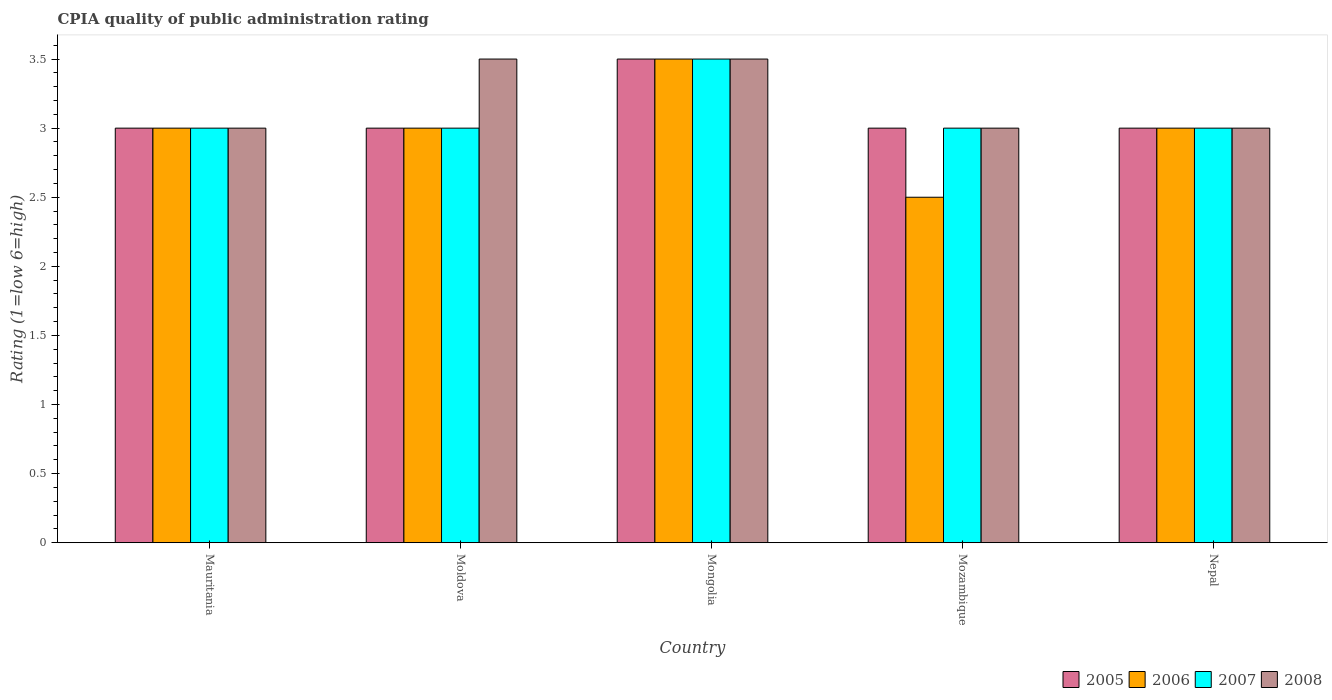How many different coloured bars are there?
Offer a terse response. 4. How many groups of bars are there?
Offer a very short reply. 5. Are the number of bars per tick equal to the number of legend labels?
Provide a succinct answer. Yes. How many bars are there on the 2nd tick from the left?
Your answer should be compact. 4. How many bars are there on the 3rd tick from the right?
Give a very brief answer. 4. What is the label of the 3rd group of bars from the left?
Offer a terse response. Mongolia. In how many cases, is the number of bars for a given country not equal to the number of legend labels?
Your answer should be compact. 0. What is the CPIA rating in 2008 in Mauritania?
Your response must be concise. 3. Across all countries, what is the maximum CPIA rating in 2006?
Offer a terse response. 3.5. In which country was the CPIA rating in 2006 maximum?
Give a very brief answer. Mongolia. In which country was the CPIA rating in 2006 minimum?
Offer a very short reply. Mozambique. What is the total CPIA rating in 2008 in the graph?
Ensure brevity in your answer.  16. What is the difference between the CPIA rating in 2006 in Mongolia and that in Mozambique?
Give a very brief answer. 1. What is the average CPIA rating in 2007 per country?
Offer a terse response. 3.1. What is the ratio of the CPIA rating in 2006 in Mauritania to that in Nepal?
Give a very brief answer. 1. Is the difference between the CPIA rating in 2008 in Mongolia and Mozambique greater than the difference between the CPIA rating in 2006 in Mongolia and Mozambique?
Your answer should be compact. No. What is the difference between the highest and the second highest CPIA rating in 2006?
Provide a short and direct response. -0.5. What is the difference between the highest and the lowest CPIA rating in 2008?
Your answer should be very brief. 0.5. In how many countries, is the CPIA rating in 2007 greater than the average CPIA rating in 2007 taken over all countries?
Your answer should be very brief. 1. What does the 1st bar from the right in Moldova represents?
Provide a succinct answer. 2008. Is it the case that in every country, the sum of the CPIA rating in 2005 and CPIA rating in 2008 is greater than the CPIA rating in 2007?
Provide a short and direct response. Yes. How many bars are there?
Your answer should be compact. 20. How many countries are there in the graph?
Ensure brevity in your answer.  5. What is the difference between two consecutive major ticks on the Y-axis?
Offer a terse response. 0.5. Are the values on the major ticks of Y-axis written in scientific E-notation?
Ensure brevity in your answer.  No. How many legend labels are there?
Ensure brevity in your answer.  4. How are the legend labels stacked?
Your response must be concise. Horizontal. What is the title of the graph?
Provide a succinct answer. CPIA quality of public administration rating. Does "2004" appear as one of the legend labels in the graph?
Ensure brevity in your answer.  No. What is the label or title of the X-axis?
Give a very brief answer. Country. What is the Rating (1=low 6=high) of 2006 in Mauritania?
Make the answer very short. 3. What is the Rating (1=low 6=high) of 2006 in Moldova?
Keep it short and to the point. 3. What is the Rating (1=low 6=high) in 2007 in Mongolia?
Provide a succinct answer. 3.5. What is the Rating (1=low 6=high) of 2007 in Mozambique?
Your response must be concise. 3. What is the Rating (1=low 6=high) of 2008 in Mozambique?
Provide a short and direct response. 3. What is the Rating (1=low 6=high) of 2006 in Nepal?
Provide a succinct answer. 3. What is the Rating (1=low 6=high) in 2007 in Nepal?
Your response must be concise. 3. What is the Rating (1=low 6=high) in 2008 in Nepal?
Make the answer very short. 3. Across all countries, what is the maximum Rating (1=low 6=high) of 2005?
Your answer should be compact. 3.5. Across all countries, what is the maximum Rating (1=low 6=high) of 2006?
Ensure brevity in your answer.  3.5. Across all countries, what is the minimum Rating (1=low 6=high) in 2005?
Offer a terse response. 3. Across all countries, what is the minimum Rating (1=low 6=high) in 2006?
Your answer should be very brief. 2.5. Across all countries, what is the minimum Rating (1=low 6=high) of 2007?
Offer a terse response. 3. Across all countries, what is the minimum Rating (1=low 6=high) of 2008?
Provide a succinct answer. 3. What is the total Rating (1=low 6=high) in 2005 in the graph?
Your answer should be very brief. 15.5. What is the total Rating (1=low 6=high) in 2006 in the graph?
Offer a terse response. 15. What is the total Rating (1=low 6=high) of 2007 in the graph?
Make the answer very short. 15.5. What is the difference between the Rating (1=low 6=high) of 2006 in Mauritania and that in Moldova?
Make the answer very short. 0. What is the difference between the Rating (1=low 6=high) of 2005 in Mauritania and that in Mongolia?
Give a very brief answer. -0.5. What is the difference between the Rating (1=low 6=high) of 2006 in Mauritania and that in Mongolia?
Provide a succinct answer. -0.5. What is the difference between the Rating (1=low 6=high) in 2005 in Mauritania and that in Mozambique?
Provide a short and direct response. 0. What is the difference between the Rating (1=low 6=high) in 2007 in Mauritania and that in Mozambique?
Provide a succinct answer. 0. What is the difference between the Rating (1=low 6=high) in 2008 in Mauritania and that in Mozambique?
Your response must be concise. 0. What is the difference between the Rating (1=low 6=high) of 2005 in Mauritania and that in Nepal?
Your answer should be very brief. 0. What is the difference between the Rating (1=low 6=high) of 2005 in Moldova and that in Mongolia?
Give a very brief answer. -0.5. What is the difference between the Rating (1=low 6=high) of 2006 in Moldova and that in Mongolia?
Your answer should be compact. -0.5. What is the difference between the Rating (1=low 6=high) of 2007 in Moldova and that in Mongolia?
Keep it short and to the point. -0.5. What is the difference between the Rating (1=low 6=high) of 2008 in Moldova and that in Mongolia?
Your response must be concise. 0. What is the difference between the Rating (1=low 6=high) of 2005 in Moldova and that in Mozambique?
Offer a very short reply. 0. What is the difference between the Rating (1=low 6=high) in 2006 in Moldova and that in Mozambique?
Make the answer very short. 0.5. What is the difference between the Rating (1=low 6=high) of 2005 in Moldova and that in Nepal?
Your response must be concise. 0. What is the difference between the Rating (1=low 6=high) in 2007 in Moldova and that in Nepal?
Your answer should be compact. 0. What is the difference between the Rating (1=low 6=high) of 2005 in Mongolia and that in Mozambique?
Your answer should be compact. 0.5. What is the difference between the Rating (1=low 6=high) in 2006 in Mongolia and that in Mozambique?
Make the answer very short. 1. What is the difference between the Rating (1=low 6=high) in 2006 in Mongolia and that in Nepal?
Your response must be concise. 0.5. What is the difference between the Rating (1=low 6=high) of 2007 in Mongolia and that in Nepal?
Provide a succinct answer. 0.5. What is the difference between the Rating (1=low 6=high) of 2005 in Mauritania and the Rating (1=low 6=high) of 2007 in Moldova?
Keep it short and to the point. 0. What is the difference between the Rating (1=low 6=high) of 2006 in Mauritania and the Rating (1=low 6=high) of 2007 in Moldova?
Ensure brevity in your answer.  0. What is the difference between the Rating (1=low 6=high) of 2007 in Mauritania and the Rating (1=low 6=high) of 2008 in Moldova?
Your response must be concise. -0.5. What is the difference between the Rating (1=low 6=high) of 2005 in Mauritania and the Rating (1=low 6=high) of 2006 in Mongolia?
Keep it short and to the point. -0.5. What is the difference between the Rating (1=low 6=high) of 2005 in Mauritania and the Rating (1=low 6=high) of 2008 in Mongolia?
Your answer should be compact. -0.5. What is the difference between the Rating (1=low 6=high) of 2006 in Mauritania and the Rating (1=low 6=high) of 2007 in Mongolia?
Make the answer very short. -0.5. What is the difference between the Rating (1=low 6=high) in 2005 in Mauritania and the Rating (1=low 6=high) in 2006 in Mozambique?
Your answer should be very brief. 0.5. What is the difference between the Rating (1=low 6=high) of 2006 in Mauritania and the Rating (1=low 6=high) of 2008 in Mozambique?
Your response must be concise. 0. What is the difference between the Rating (1=low 6=high) of 2005 in Mauritania and the Rating (1=low 6=high) of 2006 in Nepal?
Provide a short and direct response. 0. What is the difference between the Rating (1=low 6=high) of 2006 in Mauritania and the Rating (1=low 6=high) of 2007 in Nepal?
Provide a succinct answer. 0. What is the difference between the Rating (1=low 6=high) in 2006 in Mauritania and the Rating (1=low 6=high) in 2008 in Nepal?
Give a very brief answer. 0. What is the difference between the Rating (1=low 6=high) in 2005 in Moldova and the Rating (1=low 6=high) in 2006 in Mongolia?
Make the answer very short. -0.5. What is the difference between the Rating (1=low 6=high) in 2006 in Moldova and the Rating (1=low 6=high) in 2008 in Mongolia?
Your answer should be compact. -0.5. What is the difference between the Rating (1=low 6=high) in 2007 in Moldova and the Rating (1=low 6=high) in 2008 in Mongolia?
Provide a succinct answer. -0.5. What is the difference between the Rating (1=low 6=high) in 2005 in Moldova and the Rating (1=low 6=high) in 2006 in Mozambique?
Your answer should be very brief. 0.5. What is the difference between the Rating (1=low 6=high) in 2005 in Moldova and the Rating (1=low 6=high) in 2007 in Mozambique?
Your response must be concise. 0. What is the difference between the Rating (1=low 6=high) of 2006 in Moldova and the Rating (1=low 6=high) of 2007 in Mozambique?
Provide a short and direct response. 0. What is the difference between the Rating (1=low 6=high) in 2006 in Moldova and the Rating (1=low 6=high) in 2008 in Mozambique?
Provide a short and direct response. 0. What is the difference between the Rating (1=low 6=high) of 2007 in Moldova and the Rating (1=low 6=high) of 2008 in Mozambique?
Provide a short and direct response. 0. What is the difference between the Rating (1=low 6=high) of 2005 in Moldova and the Rating (1=low 6=high) of 2007 in Nepal?
Make the answer very short. 0. What is the difference between the Rating (1=low 6=high) of 2005 in Moldova and the Rating (1=low 6=high) of 2008 in Nepal?
Provide a succinct answer. 0. What is the difference between the Rating (1=low 6=high) in 2006 in Moldova and the Rating (1=low 6=high) in 2007 in Nepal?
Keep it short and to the point. 0. What is the difference between the Rating (1=low 6=high) in 2006 in Moldova and the Rating (1=low 6=high) in 2008 in Nepal?
Provide a succinct answer. 0. What is the difference between the Rating (1=low 6=high) in 2005 in Mongolia and the Rating (1=low 6=high) in 2006 in Mozambique?
Provide a succinct answer. 1. What is the difference between the Rating (1=low 6=high) in 2005 in Mongolia and the Rating (1=low 6=high) in 2007 in Mozambique?
Keep it short and to the point. 0.5. What is the difference between the Rating (1=low 6=high) in 2005 in Mongolia and the Rating (1=low 6=high) in 2006 in Nepal?
Your response must be concise. 0.5. What is the difference between the Rating (1=low 6=high) of 2005 in Mongolia and the Rating (1=low 6=high) of 2007 in Nepal?
Provide a short and direct response. 0.5. What is the difference between the Rating (1=low 6=high) in 2006 in Mongolia and the Rating (1=low 6=high) in 2007 in Nepal?
Your answer should be compact. 0.5. What is the difference between the Rating (1=low 6=high) in 2005 in Mozambique and the Rating (1=low 6=high) in 2006 in Nepal?
Ensure brevity in your answer.  0. What is the difference between the Rating (1=low 6=high) of 2005 in Mozambique and the Rating (1=low 6=high) of 2007 in Nepal?
Offer a terse response. 0. What is the difference between the Rating (1=low 6=high) in 2005 in Mozambique and the Rating (1=low 6=high) in 2008 in Nepal?
Give a very brief answer. 0. What is the difference between the Rating (1=low 6=high) of 2006 in Mozambique and the Rating (1=low 6=high) of 2007 in Nepal?
Offer a very short reply. -0.5. What is the difference between the Rating (1=low 6=high) of 2006 in Mozambique and the Rating (1=low 6=high) of 2008 in Nepal?
Offer a very short reply. -0.5. What is the difference between the Rating (1=low 6=high) in 2007 in Mozambique and the Rating (1=low 6=high) in 2008 in Nepal?
Ensure brevity in your answer.  0. What is the average Rating (1=low 6=high) of 2005 per country?
Offer a terse response. 3.1. What is the average Rating (1=low 6=high) in 2006 per country?
Your response must be concise. 3. What is the average Rating (1=low 6=high) of 2008 per country?
Offer a very short reply. 3.2. What is the difference between the Rating (1=low 6=high) of 2006 and Rating (1=low 6=high) of 2008 in Mauritania?
Offer a very short reply. 0. What is the difference between the Rating (1=low 6=high) of 2007 and Rating (1=low 6=high) of 2008 in Mauritania?
Provide a succinct answer. 0. What is the difference between the Rating (1=low 6=high) in 2005 and Rating (1=low 6=high) in 2008 in Moldova?
Your answer should be compact. -0.5. What is the difference between the Rating (1=low 6=high) of 2007 and Rating (1=low 6=high) of 2008 in Moldova?
Provide a short and direct response. -0.5. What is the difference between the Rating (1=low 6=high) of 2005 and Rating (1=low 6=high) of 2007 in Mongolia?
Give a very brief answer. 0. What is the difference between the Rating (1=low 6=high) of 2005 and Rating (1=low 6=high) of 2008 in Mongolia?
Give a very brief answer. 0. What is the difference between the Rating (1=low 6=high) in 2006 and Rating (1=low 6=high) in 2007 in Mongolia?
Ensure brevity in your answer.  0. What is the difference between the Rating (1=low 6=high) in 2007 and Rating (1=low 6=high) in 2008 in Mongolia?
Provide a succinct answer. 0. What is the difference between the Rating (1=low 6=high) of 2005 and Rating (1=low 6=high) of 2008 in Mozambique?
Offer a very short reply. 0. What is the difference between the Rating (1=low 6=high) in 2006 and Rating (1=low 6=high) in 2007 in Mozambique?
Provide a succinct answer. -0.5. What is the difference between the Rating (1=low 6=high) of 2006 and Rating (1=low 6=high) of 2008 in Mozambique?
Your answer should be very brief. -0.5. What is the difference between the Rating (1=low 6=high) of 2005 and Rating (1=low 6=high) of 2007 in Nepal?
Provide a short and direct response. 0. What is the difference between the Rating (1=low 6=high) of 2006 and Rating (1=low 6=high) of 2008 in Nepal?
Offer a very short reply. 0. What is the ratio of the Rating (1=low 6=high) in 2005 in Mauritania to that in Moldova?
Keep it short and to the point. 1. What is the ratio of the Rating (1=low 6=high) in 2008 in Mauritania to that in Moldova?
Ensure brevity in your answer.  0.86. What is the ratio of the Rating (1=low 6=high) in 2005 in Mauritania to that in Mongolia?
Your answer should be very brief. 0.86. What is the ratio of the Rating (1=low 6=high) in 2006 in Mauritania to that in Mongolia?
Your answer should be very brief. 0.86. What is the ratio of the Rating (1=low 6=high) in 2006 in Mauritania to that in Mozambique?
Give a very brief answer. 1.2. What is the ratio of the Rating (1=low 6=high) of 2007 in Mauritania to that in Mozambique?
Offer a terse response. 1. What is the ratio of the Rating (1=low 6=high) in 2008 in Mauritania to that in Mozambique?
Make the answer very short. 1. What is the ratio of the Rating (1=low 6=high) of 2006 in Mauritania to that in Nepal?
Your response must be concise. 1. What is the ratio of the Rating (1=low 6=high) of 2007 in Mauritania to that in Nepal?
Give a very brief answer. 1. What is the ratio of the Rating (1=low 6=high) in 2005 in Moldova to that in Mongolia?
Your response must be concise. 0.86. What is the ratio of the Rating (1=low 6=high) of 2008 in Moldova to that in Mongolia?
Your response must be concise. 1. What is the ratio of the Rating (1=low 6=high) of 2005 in Moldova to that in Mozambique?
Ensure brevity in your answer.  1. What is the ratio of the Rating (1=low 6=high) in 2006 in Moldova to that in Mozambique?
Your response must be concise. 1.2. What is the ratio of the Rating (1=low 6=high) in 2007 in Moldova to that in Mozambique?
Give a very brief answer. 1. What is the ratio of the Rating (1=low 6=high) of 2008 in Moldova to that in Mozambique?
Make the answer very short. 1.17. What is the ratio of the Rating (1=low 6=high) in 2005 in Moldova to that in Nepal?
Keep it short and to the point. 1. What is the ratio of the Rating (1=low 6=high) in 2006 in Moldova to that in Nepal?
Provide a short and direct response. 1. What is the ratio of the Rating (1=low 6=high) in 2007 in Moldova to that in Nepal?
Provide a short and direct response. 1. What is the ratio of the Rating (1=low 6=high) of 2008 in Mongolia to that in Mozambique?
Provide a short and direct response. 1.17. What is the ratio of the Rating (1=low 6=high) in 2005 in Mongolia to that in Nepal?
Offer a very short reply. 1.17. What is the ratio of the Rating (1=low 6=high) of 2005 in Mozambique to that in Nepal?
Offer a terse response. 1. What is the ratio of the Rating (1=low 6=high) in 2006 in Mozambique to that in Nepal?
Provide a short and direct response. 0.83. What is the ratio of the Rating (1=low 6=high) in 2007 in Mozambique to that in Nepal?
Your answer should be compact. 1. What is the ratio of the Rating (1=low 6=high) in 2008 in Mozambique to that in Nepal?
Offer a very short reply. 1. What is the difference between the highest and the second highest Rating (1=low 6=high) in 2006?
Give a very brief answer. 0.5. What is the difference between the highest and the second highest Rating (1=low 6=high) in 2007?
Offer a very short reply. 0.5. What is the difference between the highest and the second highest Rating (1=low 6=high) of 2008?
Keep it short and to the point. 0. What is the difference between the highest and the lowest Rating (1=low 6=high) of 2006?
Ensure brevity in your answer.  1. What is the difference between the highest and the lowest Rating (1=low 6=high) of 2007?
Ensure brevity in your answer.  0.5. What is the difference between the highest and the lowest Rating (1=low 6=high) in 2008?
Your answer should be very brief. 0.5. 